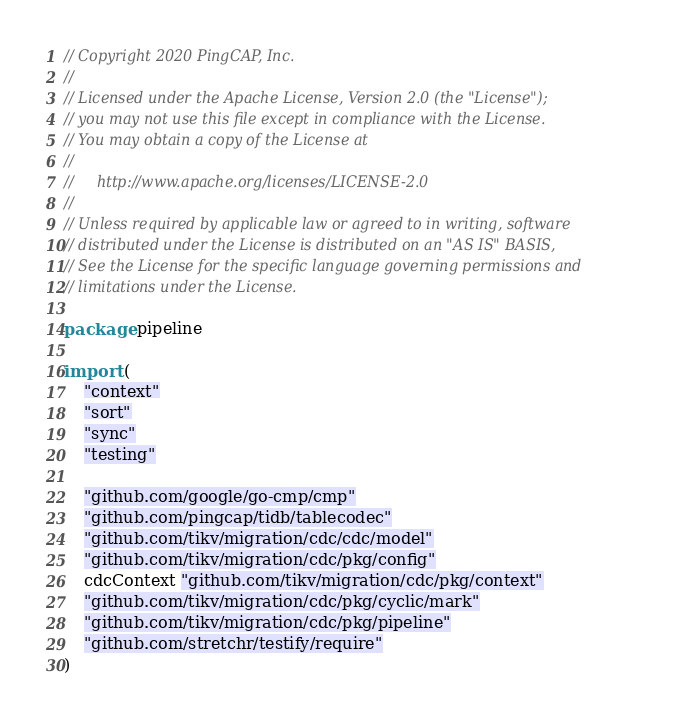Convert code to text. <code><loc_0><loc_0><loc_500><loc_500><_Go_>// Copyright 2020 PingCAP, Inc.
//
// Licensed under the Apache License, Version 2.0 (the "License");
// you may not use this file except in compliance with the License.
// You may obtain a copy of the License at
//
//     http://www.apache.org/licenses/LICENSE-2.0
//
// Unless required by applicable law or agreed to in writing, software
// distributed under the License is distributed on an "AS IS" BASIS,
// See the License for the specific language governing permissions and
// limitations under the License.

package pipeline

import (
	"context"
	"sort"
	"sync"
	"testing"

	"github.com/google/go-cmp/cmp"
	"github.com/pingcap/tidb/tablecodec"
	"github.com/tikv/migration/cdc/cdc/model"
	"github.com/tikv/migration/cdc/pkg/config"
	cdcContext "github.com/tikv/migration/cdc/pkg/context"
	"github.com/tikv/migration/cdc/pkg/cyclic/mark"
	"github.com/tikv/migration/cdc/pkg/pipeline"
	"github.com/stretchr/testify/require"
)
</code> 